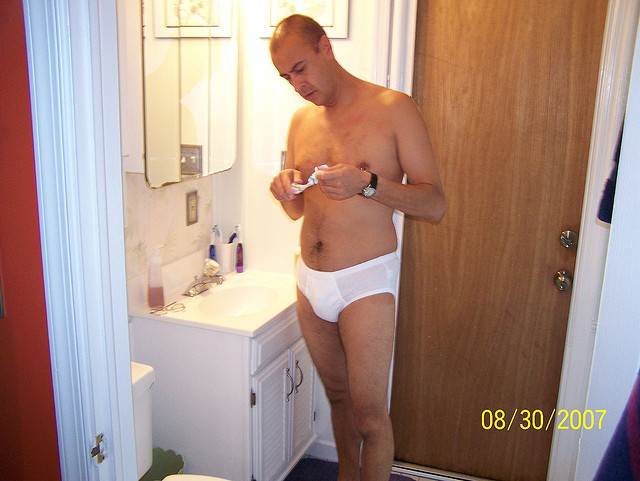<image>What color is the trash can? It is unknown what color the trash can is. It could be green, white, gray, or black. What color is the trash can? I am not sure what color is the trash can. It can be seen green, white, gray, black or there is no trash can in the image. 